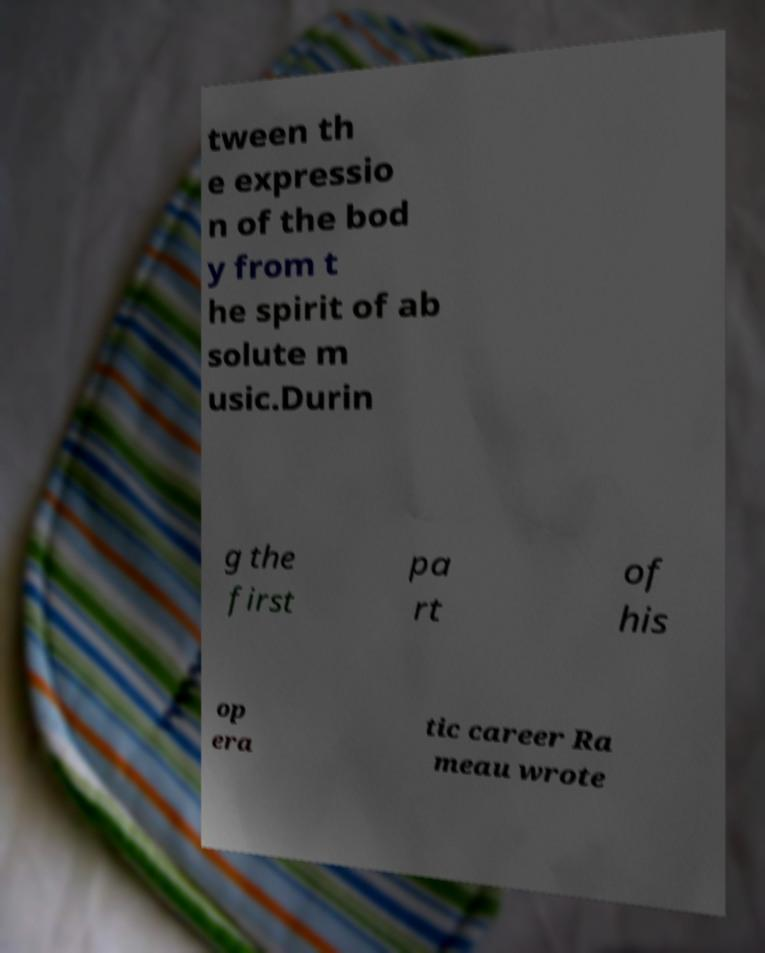Can you read and provide the text displayed in the image?This photo seems to have some interesting text. Can you extract and type it out for me? tween th e expressio n of the bod y from t he spirit of ab solute m usic.Durin g the first pa rt of his op era tic career Ra meau wrote 